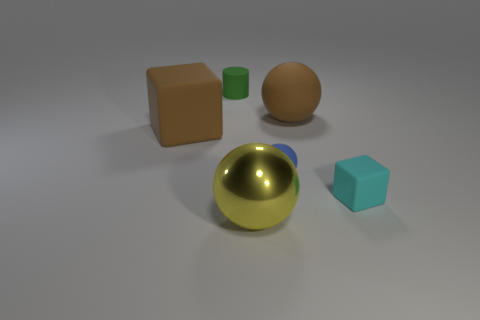How many other objects are the same material as the small blue thing?
Provide a succinct answer. 4. Are there any other things that are the same shape as the green rubber thing?
Keep it short and to the point. No. The big ball that is behind the rubber ball left of the large sphere that is behind the cyan matte thing is what color?
Keep it short and to the point. Brown. The object that is both on the right side of the small blue thing and in front of the small sphere has what shape?
Your answer should be compact. Cube. What color is the matte cube in front of the cube to the left of the tiny blue rubber ball?
Your response must be concise. Cyan. There is a small object behind the brown matte object in front of the sphere that is behind the tiny sphere; what shape is it?
Your answer should be very brief. Cylinder. There is a ball that is to the left of the big rubber sphere and behind the tiny cyan object; what is its size?
Offer a very short reply. Small. How many cylinders are the same color as the large metal object?
Give a very brief answer. 0. What is the large cube made of?
Your answer should be very brief. Rubber. Are the sphere that is to the right of the small blue matte ball and the blue object made of the same material?
Keep it short and to the point. Yes. 